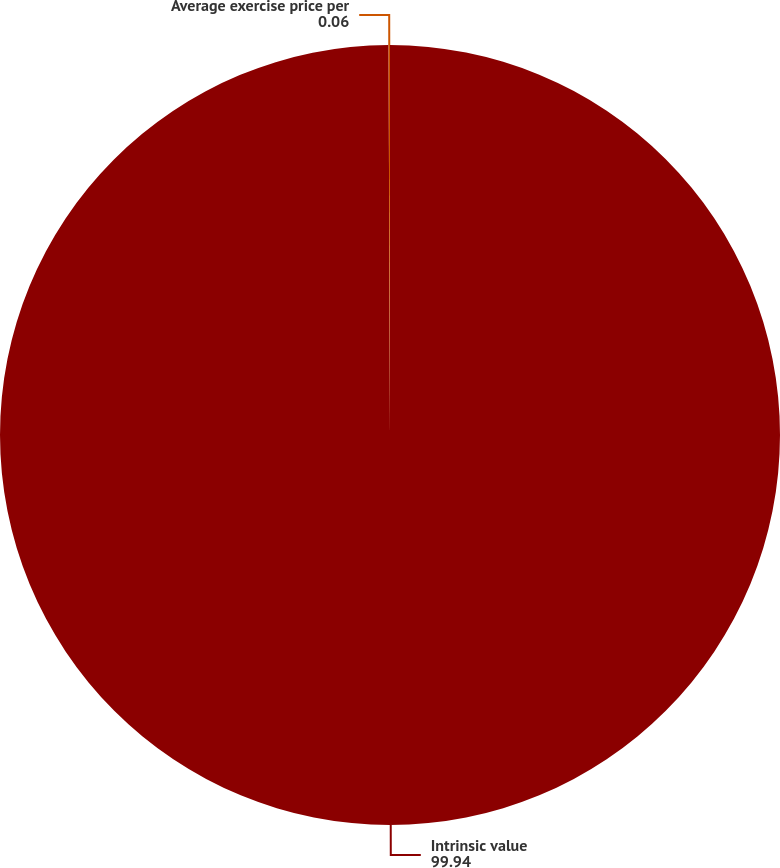Convert chart. <chart><loc_0><loc_0><loc_500><loc_500><pie_chart><fcel>Intrinsic value<fcel>Average exercise price per<nl><fcel>99.94%<fcel>0.06%<nl></chart> 